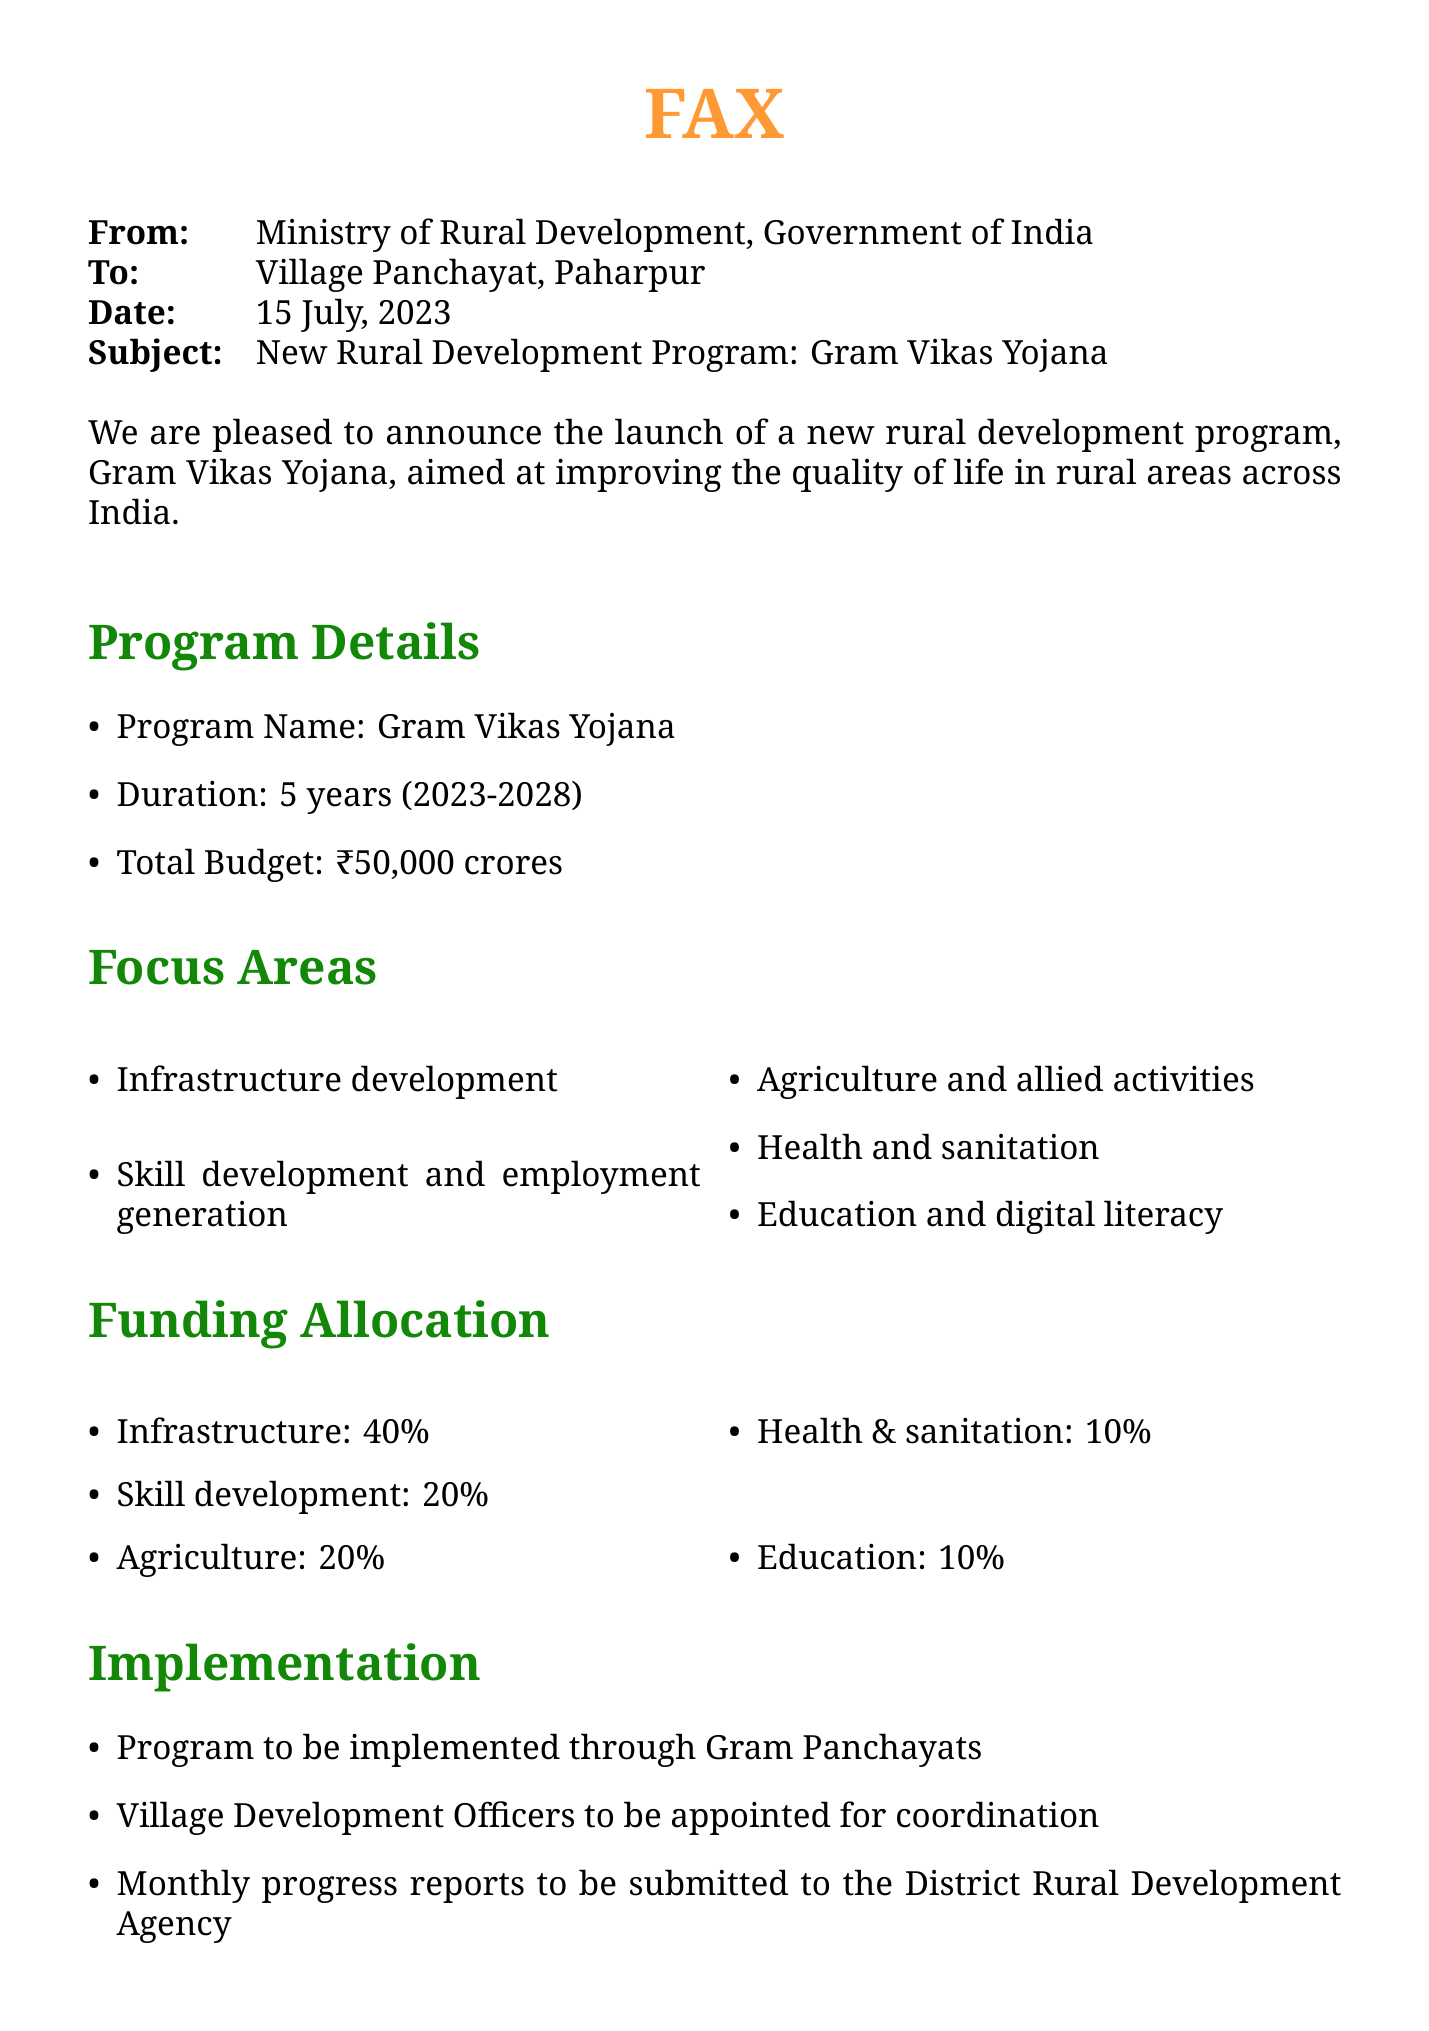What is the name of the new program? The document states that the program is called Gram Vikas Yojana.
Answer: Gram Vikas Yojana How long will the program last? The duration of the program is mentioned as 5 years.
Answer: 5 years What is the total budget for the program? The total budget specified in the document is ₹50,000 crores.
Answer: ₹50,000 crores What percentage of the budget is allocated to infrastructure development? The funding allocation for infrastructure development is stated as 40%.
Answer: 40% Who is responsible for implementing the program? The document mentions that the program will be implemented through Gram Panchayats.
Answer: Gram Panchayats What is one of the focus areas of the program? The document lists several focus areas, one of which is health and sanitation.
Answer: Health and sanitation When is the training workshop for Panchayat members scheduled? The document states that the training workshop is on 1st August, 2023.
Answer: 1st August, 2023 Who can be contacted for more information? The contact information provides Rajesh Kumar as the point of contact.
Answer: Rajesh Kumar What is the next step after conducting the Gram Sabha meeting? According to the document, the next step is to submit a village-specific development plan.
Answer: Submit village-specific development plan 